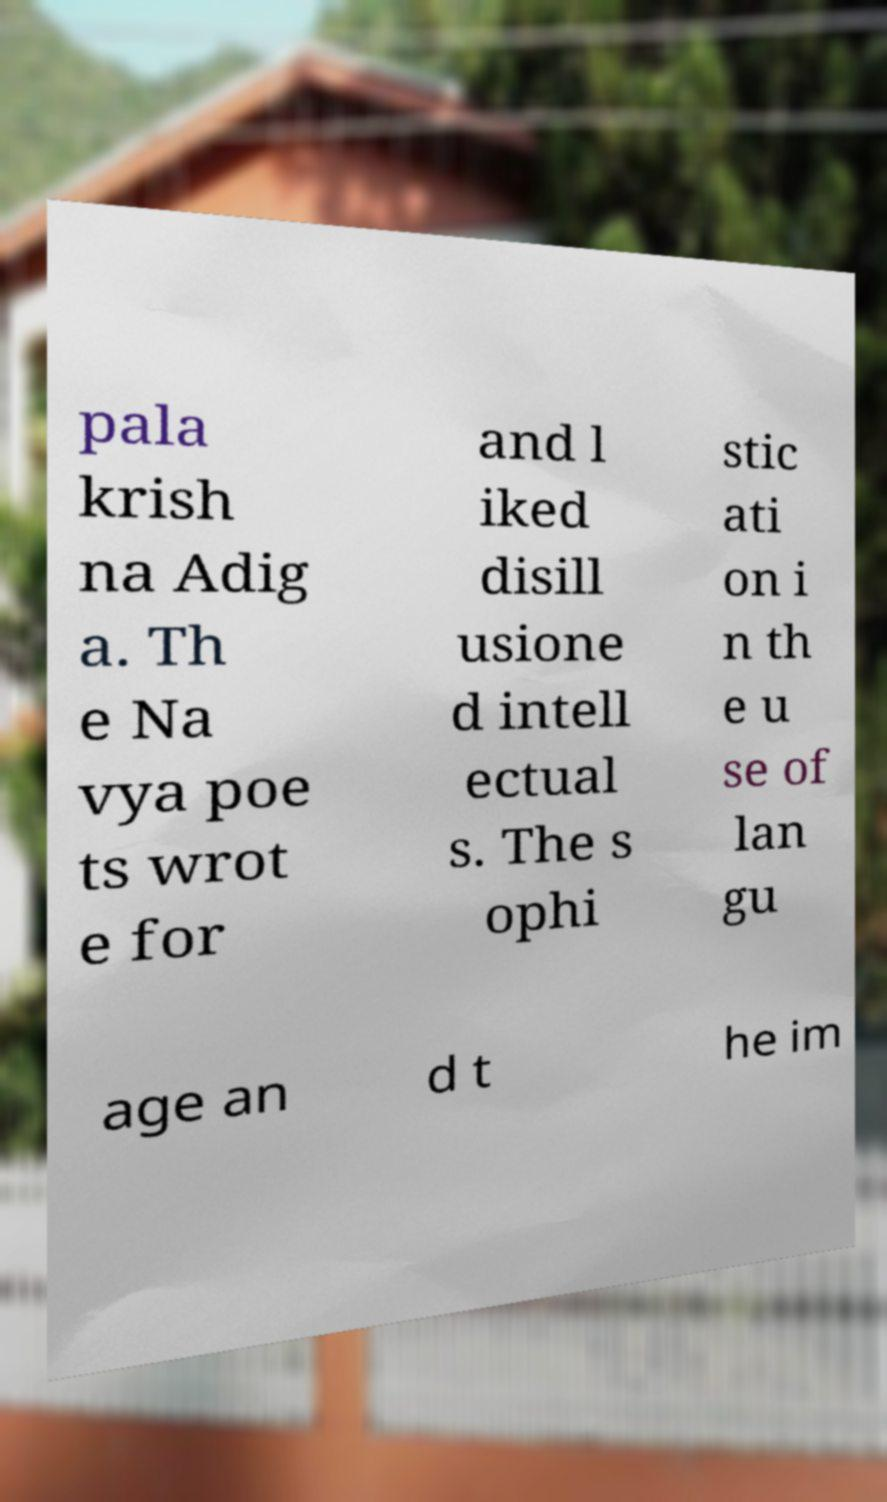There's text embedded in this image that I need extracted. Can you transcribe it verbatim? pala krish na Adig a. Th e Na vya poe ts wrot e for and l iked disill usione d intell ectual s. The s ophi stic ati on i n th e u se of lan gu age an d t he im 